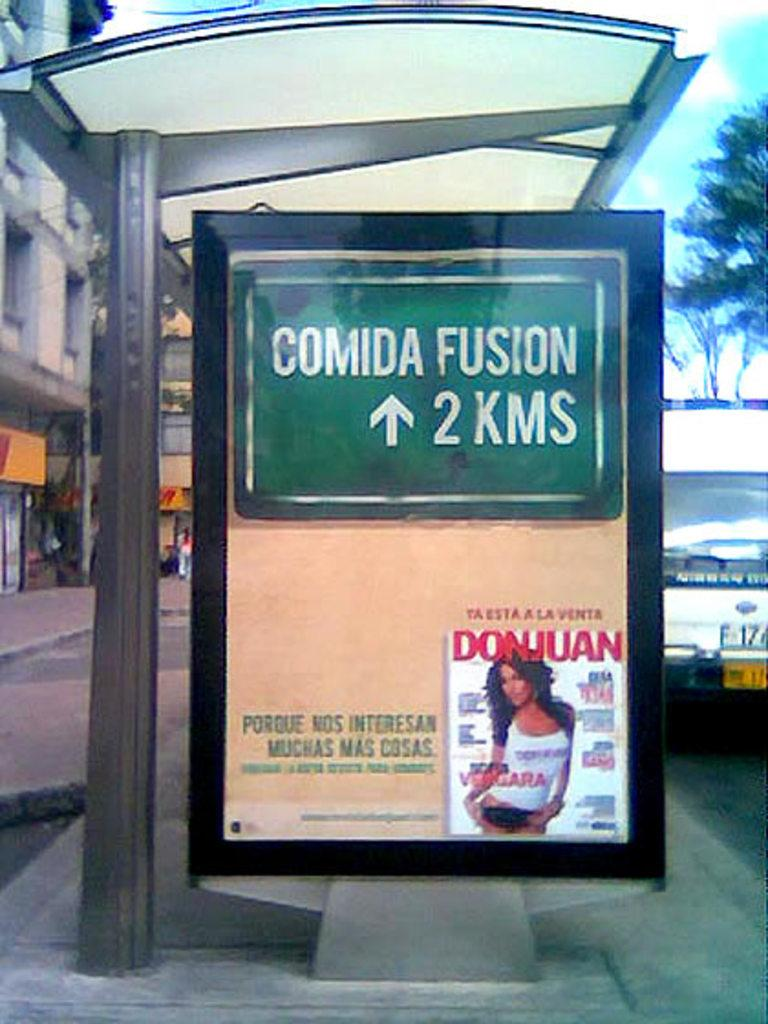Provide a one-sentence caption for the provided image. A bus shelter with an ad for a magazine called DonJuan at the bottom. 